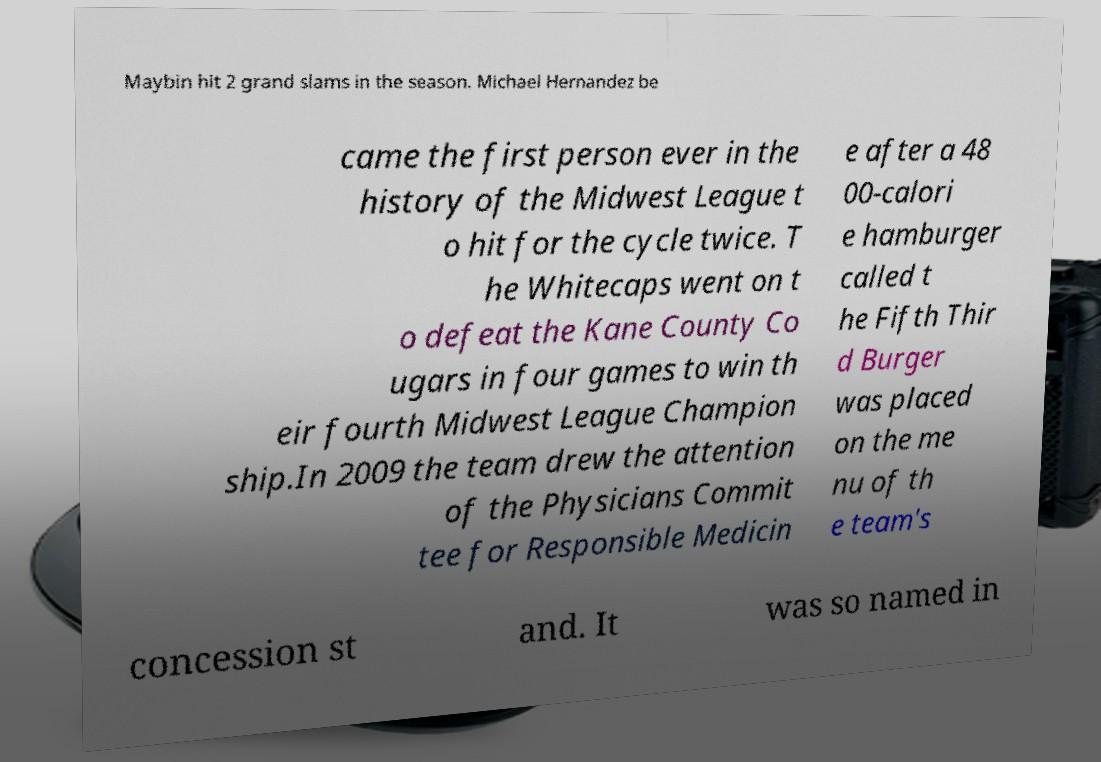Could you assist in decoding the text presented in this image and type it out clearly? Maybin hit 2 grand slams in the season. Michael Hernandez be came the first person ever in the history of the Midwest League t o hit for the cycle twice. T he Whitecaps went on t o defeat the Kane County Co ugars in four games to win th eir fourth Midwest League Champion ship.In 2009 the team drew the attention of the Physicians Commit tee for Responsible Medicin e after a 48 00-calori e hamburger called t he Fifth Thir d Burger was placed on the me nu of th e team's concession st and. It was so named in 